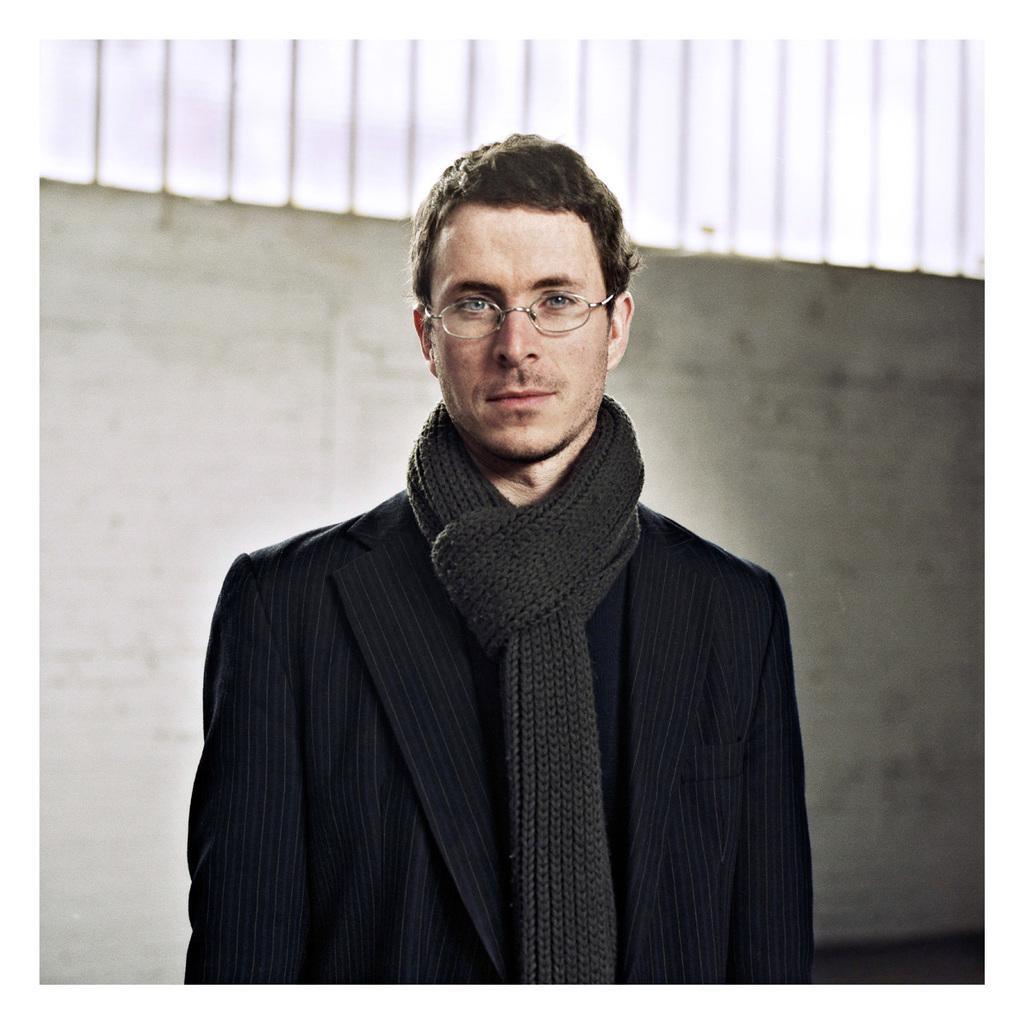How would you summarize this image in a sentence or two? In this image I can see a person standing wearing black color dress, background I can see wall in white color and sky also in white color. 